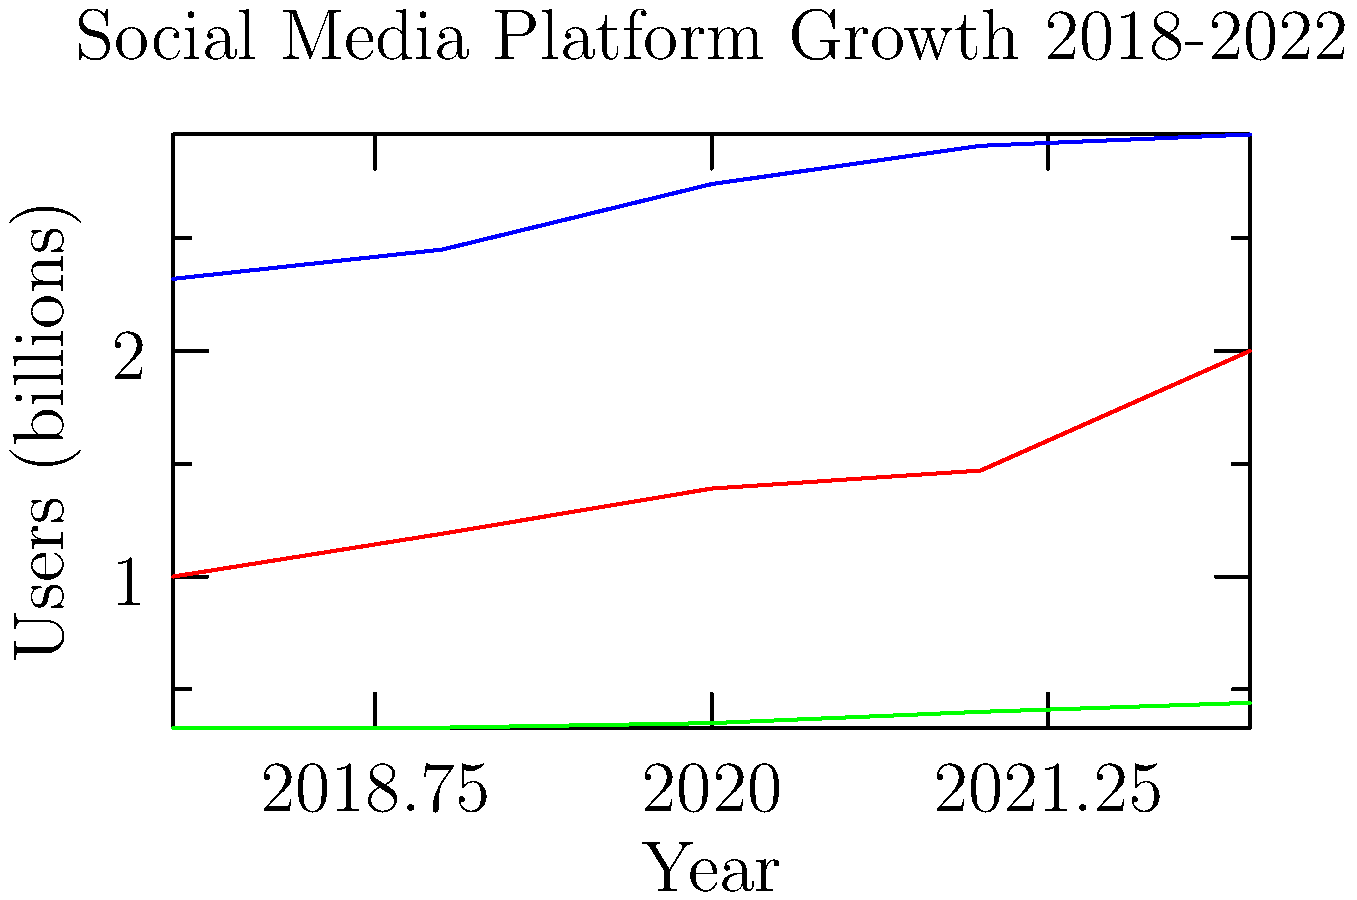As a news editor at an online technology blog, you're analyzing the growth trends of major social media platforms. Based on the line graph showing user growth from 2018 to 2022, which platform demonstrated the most consistent year-over-year growth rate, and what implications might this have for technology advertisers? To determine the most consistent year-over-year growth rate, we need to analyze each platform's growth pattern:

1. Facebook:
   2018-2019: 5.6% increase
   2019-2020: 11.8% increase
   2020-2021: 6.2% increase
   2021-2022: 1.7% increase
   Observation: Inconsistent growth rates, with a significant spike in 2019-2020.

2. Instagram:
   2018-2019: 19% increase
   2019-2020: 16.8% increase
   2020-2021: 5.8% increase
   2021-2022: 36.1% increase
   Observation: Highly variable growth rates, with a massive spike in 2021-2022.

3. Twitter:
   2018-2019: 0% increase
   2019-2020: 6.1% increase
   2020-2021: 14.3% increase
   2021-2022: 10% increase
   Observation: More consistent growth rates from 2019 onwards, with a slight decrease in the last year.

Twitter shows the most consistent year-over-year growth rate, especially from 2019 to 2022. While its growth is slower than the other platforms, it's more stable and predictable.

Implications for technology advertisers:
1. Predictability: Twitter's consistent growth allows for more accurate forecasting of audience reach and ad performance.
2. Targeted advertising: Twitter's steady growth might indicate a loyal user base, potentially offering more effective targeted advertising opportunities.
3. Long-term strategy: Advertisers may consider Twitter for long-term campaigns due to its stable growth, as opposed to platforms with more volatile user numbers.
4. Diversification: While other platforms show higher overall growth, their inconsistency might encourage advertisers to diversify their ad spend across multiple platforms to mitigate risks.
5. Niche marketing: Twitter's smaller but consistently growing user base might be ideal for niche market targeting or B2B advertising.
Answer: Twitter; predictable audience growth for long-term ad strategies 